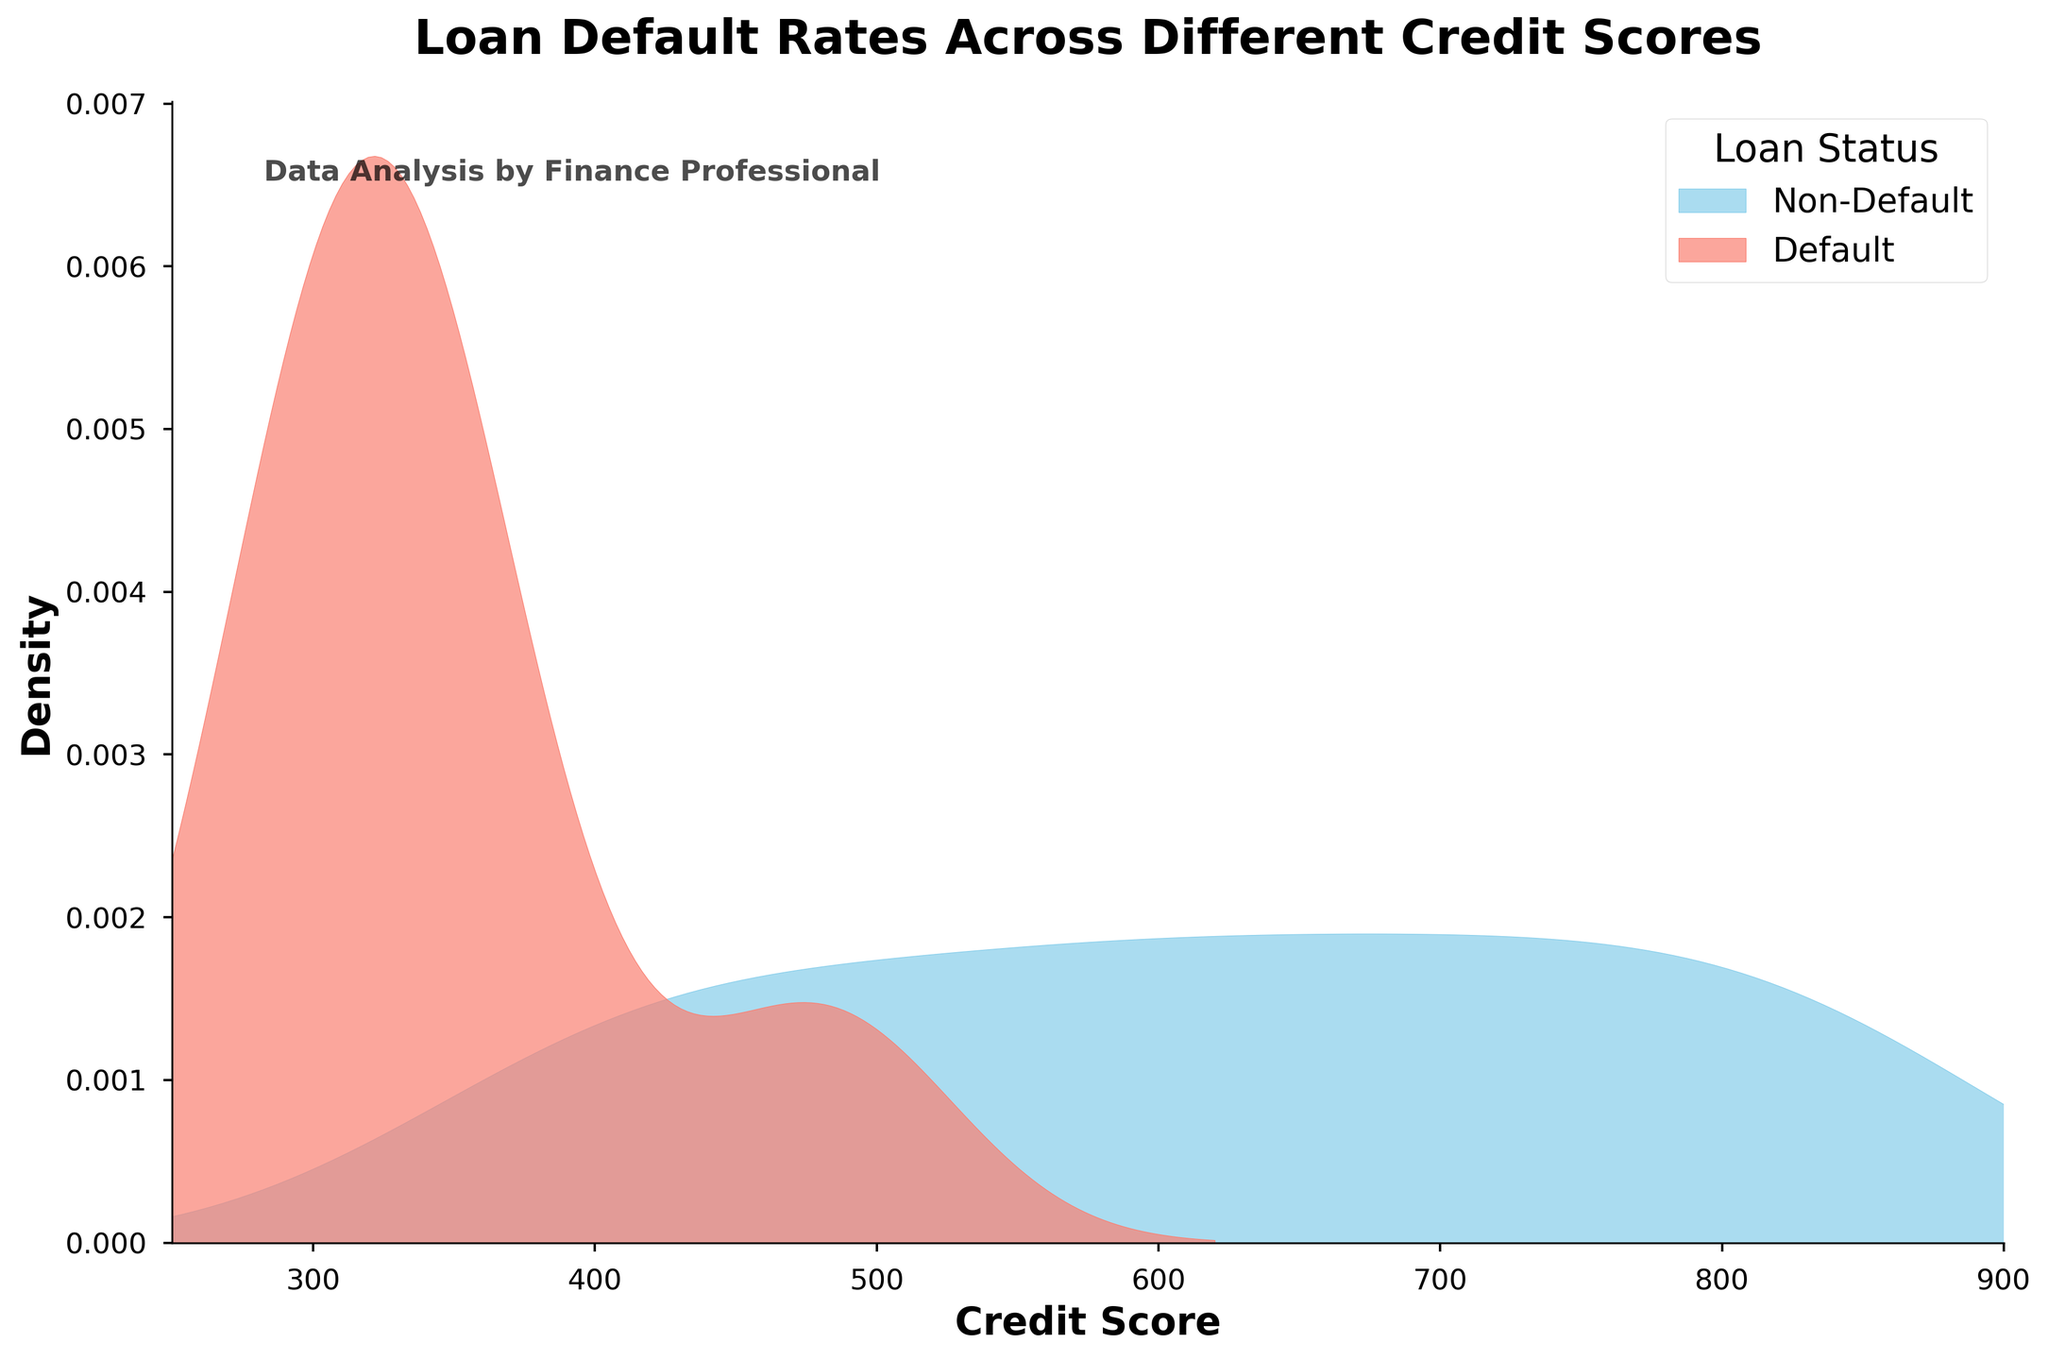What is the title of the plot? The title of the plot is visible at the top and it reads 'Loan Default Rates Across Different Credit Scores'.
Answer: Loan Default Rates Across Different Credit Scores What do the colors 'skyblue' and 'salmon' represent in the plot? The legend at the right side indicates that 'skyblue' represents 'Non-Default' and 'salmon' represents 'Default'.
Answer: 'skyblue' represents 'Non-Default', 'salmon' represents 'Default' What is the credit score range shown on the x-axis? The x-axis range can be observed with values from 250 to 900, as indicated by the ticks and axis limits.
Answer: 250 to 900 At which credit score does the density of defaults appear to be the highest? The peak of the salmon-colored density curve, representing defaults, occurs around a credit score of 320.
Answer: 320 How many groups are compared in this plot? The plot compares two groups, as indicated by the two different density curves and the legend labels for 'Non-Default' and 'Default'.
Answer: 2 groups Which group has a higher density for credit scores around 700? Observing the plot, the skyblue density curve is higher than the salmon density curve around the credit score of 700.
Answer: Non-Default Do the default and non-default distributions overlap? The overlapped areas show both the skyblue and salmon density curves superimposed at certain credit scores, indicating overlap.
Answer: Yes Describe the overall shape of the density curve for the 'Non-Default' group. The skyblue density curve for 'Non-Default' starts low, peaks around 700, and gradually declines. It is almost symmetrical and concentrated around higher credit scores.
Answer: Peaked around 700, symmetrical, concentrates at higher scores Compare the spread of credit scores between 'Default' and 'Non-Default' groups. The 'Default' group's density curve is narrow and peaks sharply around 320, while the 'Non-Default' group has a wider spread with a broader peak around 700.
Answer: 'Default' is narrow and peaks at 320, 'Non-Default' is wider and peaks at 700 How are the axes titled in the plot? Observing the plot, the x-axis is titled 'Credit Score' and the y-axis is titled 'Density'.
Answer: 'Credit Score' for the x-axis, 'Density' for the y-axis 